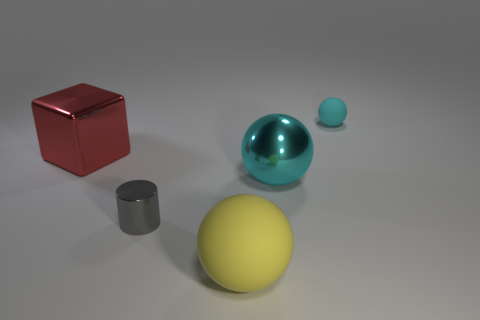What number of big yellow matte things are there?
Give a very brief answer. 1. What number of cyan things are either small shiny objects or small metal blocks?
Offer a very short reply. 0. How many other things are the same shape as the small gray shiny thing?
Keep it short and to the point. 0. There is a rubber object in front of the small gray metal object; is it the same color as the small thing in front of the small cyan rubber object?
Your response must be concise. No. What number of small objects are red balls or cylinders?
Keep it short and to the point. 1. What size is the yellow thing that is the same shape as the small cyan rubber object?
Offer a very short reply. Large. Is there any other thing that has the same size as the gray metallic object?
Your answer should be compact. Yes. There is a large object that is in front of the tiny object left of the big matte sphere; what is its material?
Offer a very short reply. Rubber. What number of shiny things are cyan spheres or big cubes?
Offer a very short reply. 2. What color is the other tiny rubber object that is the same shape as the yellow matte thing?
Keep it short and to the point. Cyan. 